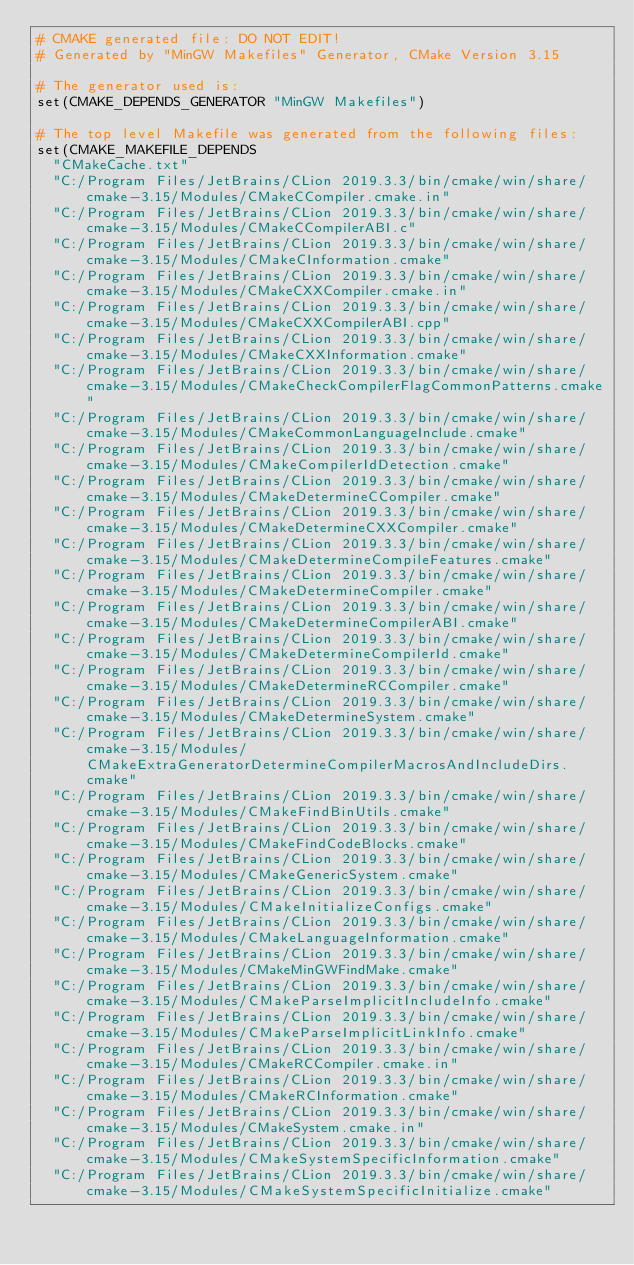<code> <loc_0><loc_0><loc_500><loc_500><_CMake_># CMAKE generated file: DO NOT EDIT!
# Generated by "MinGW Makefiles" Generator, CMake Version 3.15

# The generator used is:
set(CMAKE_DEPENDS_GENERATOR "MinGW Makefiles")

# The top level Makefile was generated from the following files:
set(CMAKE_MAKEFILE_DEPENDS
  "CMakeCache.txt"
  "C:/Program Files/JetBrains/CLion 2019.3.3/bin/cmake/win/share/cmake-3.15/Modules/CMakeCCompiler.cmake.in"
  "C:/Program Files/JetBrains/CLion 2019.3.3/bin/cmake/win/share/cmake-3.15/Modules/CMakeCCompilerABI.c"
  "C:/Program Files/JetBrains/CLion 2019.3.3/bin/cmake/win/share/cmake-3.15/Modules/CMakeCInformation.cmake"
  "C:/Program Files/JetBrains/CLion 2019.3.3/bin/cmake/win/share/cmake-3.15/Modules/CMakeCXXCompiler.cmake.in"
  "C:/Program Files/JetBrains/CLion 2019.3.3/bin/cmake/win/share/cmake-3.15/Modules/CMakeCXXCompilerABI.cpp"
  "C:/Program Files/JetBrains/CLion 2019.3.3/bin/cmake/win/share/cmake-3.15/Modules/CMakeCXXInformation.cmake"
  "C:/Program Files/JetBrains/CLion 2019.3.3/bin/cmake/win/share/cmake-3.15/Modules/CMakeCheckCompilerFlagCommonPatterns.cmake"
  "C:/Program Files/JetBrains/CLion 2019.3.3/bin/cmake/win/share/cmake-3.15/Modules/CMakeCommonLanguageInclude.cmake"
  "C:/Program Files/JetBrains/CLion 2019.3.3/bin/cmake/win/share/cmake-3.15/Modules/CMakeCompilerIdDetection.cmake"
  "C:/Program Files/JetBrains/CLion 2019.3.3/bin/cmake/win/share/cmake-3.15/Modules/CMakeDetermineCCompiler.cmake"
  "C:/Program Files/JetBrains/CLion 2019.3.3/bin/cmake/win/share/cmake-3.15/Modules/CMakeDetermineCXXCompiler.cmake"
  "C:/Program Files/JetBrains/CLion 2019.3.3/bin/cmake/win/share/cmake-3.15/Modules/CMakeDetermineCompileFeatures.cmake"
  "C:/Program Files/JetBrains/CLion 2019.3.3/bin/cmake/win/share/cmake-3.15/Modules/CMakeDetermineCompiler.cmake"
  "C:/Program Files/JetBrains/CLion 2019.3.3/bin/cmake/win/share/cmake-3.15/Modules/CMakeDetermineCompilerABI.cmake"
  "C:/Program Files/JetBrains/CLion 2019.3.3/bin/cmake/win/share/cmake-3.15/Modules/CMakeDetermineCompilerId.cmake"
  "C:/Program Files/JetBrains/CLion 2019.3.3/bin/cmake/win/share/cmake-3.15/Modules/CMakeDetermineRCCompiler.cmake"
  "C:/Program Files/JetBrains/CLion 2019.3.3/bin/cmake/win/share/cmake-3.15/Modules/CMakeDetermineSystem.cmake"
  "C:/Program Files/JetBrains/CLion 2019.3.3/bin/cmake/win/share/cmake-3.15/Modules/CMakeExtraGeneratorDetermineCompilerMacrosAndIncludeDirs.cmake"
  "C:/Program Files/JetBrains/CLion 2019.3.3/bin/cmake/win/share/cmake-3.15/Modules/CMakeFindBinUtils.cmake"
  "C:/Program Files/JetBrains/CLion 2019.3.3/bin/cmake/win/share/cmake-3.15/Modules/CMakeFindCodeBlocks.cmake"
  "C:/Program Files/JetBrains/CLion 2019.3.3/bin/cmake/win/share/cmake-3.15/Modules/CMakeGenericSystem.cmake"
  "C:/Program Files/JetBrains/CLion 2019.3.3/bin/cmake/win/share/cmake-3.15/Modules/CMakeInitializeConfigs.cmake"
  "C:/Program Files/JetBrains/CLion 2019.3.3/bin/cmake/win/share/cmake-3.15/Modules/CMakeLanguageInformation.cmake"
  "C:/Program Files/JetBrains/CLion 2019.3.3/bin/cmake/win/share/cmake-3.15/Modules/CMakeMinGWFindMake.cmake"
  "C:/Program Files/JetBrains/CLion 2019.3.3/bin/cmake/win/share/cmake-3.15/Modules/CMakeParseImplicitIncludeInfo.cmake"
  "C:/Program Files/JetBrains/CLion 2019.3.3/bin/cmake/win/share/cmake-3.15/Modules/CMakeParseImplicitLinkInfo.cmake"
  "C:/Program Files/JetBrains/CLion 2019.3.3/bin/cmake/win/share/cmake-3.15/Modules/CMakeRCCompiler.cmake.in"
  "C:/Program Files/JetBrains/CLion 2019.3.3/bin/cmake/win/share/cmake-3.15/Modules/CMakeRCInformation.cmake"
  "C:/Program Files/JetBrains/CLion 2019.3.3/bin/cmake/win/share/cmake-3.15/Modules/CMakeSystem.cmake.in"
  "C:/Program Files/JetBrains/CLion 2019.3.3/bin/cmake/win/share/cmake-3.15/Modules/CMakeSystemSpecificInformation.cmake"
  "C:/Program Files/JetBrains/CLion 2019.3.3/bin/cmake/win/share/cmake-3.15/Modules/CMakeSystemSpecificInitialize.cmake"</code> 